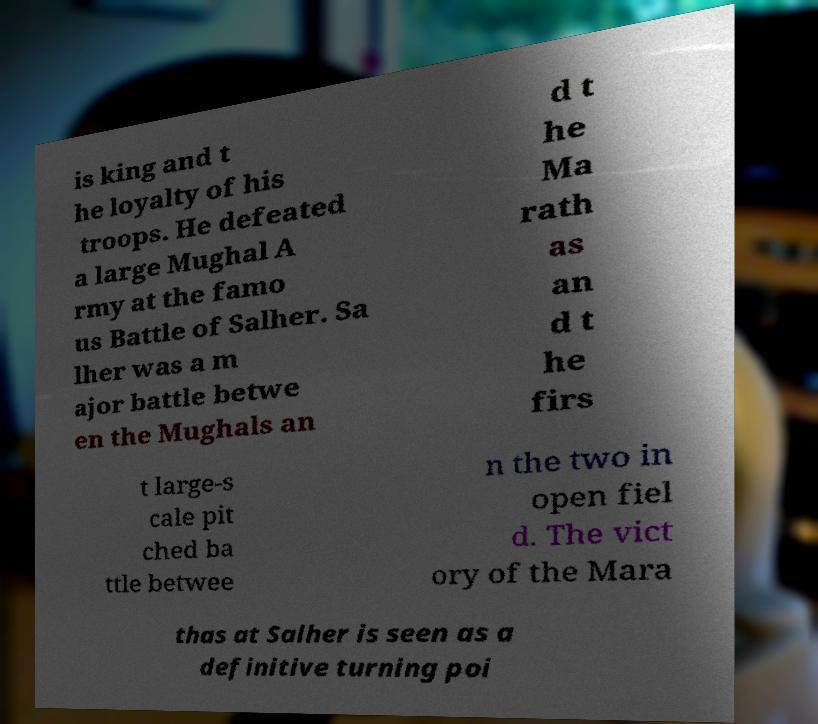Please identify and transcribe the text found in this image. is king and t he loyalty of his troops. He defeated a large Mughal A rmy at the famo us Battle of Salher. Sa lher was a m ajor battle betwe en the Mughals an d t he Ma rath as an d t he firs t large-s cale pit ched ba ttle betwee n the two in open fiel d. The vict ory of the Mara thas at Salher is seen as a definitive turning poi 